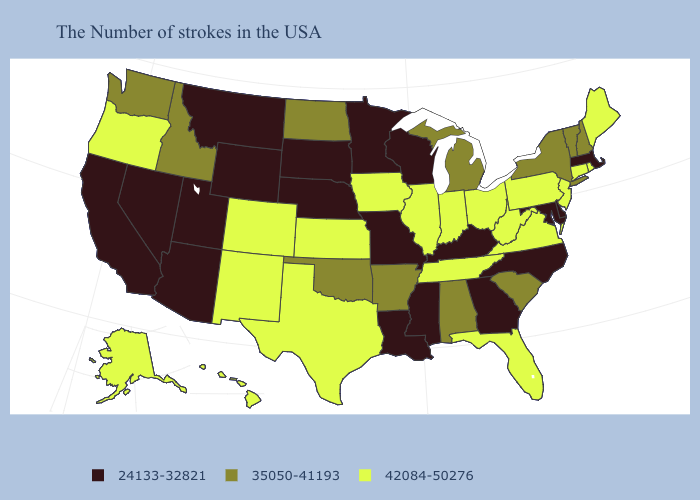What is the value of Wisconsin?
Keep it brief. 24133-32821. Among the states that border South Dakota , which have the lowest value?
Give a very brief answer. Minnesota, Nebraska, Wyoming, Montana. Name the states that have a value in the range 42084-50276?
Keep it brief. Maine, Rhode Island, Connecticut, New Jersey, Pennsylvania, Virginia, West Virginia, Ohio, Florida, Indiana, Tennessee, Illinois, Iowa, Kansas, Texas, Colorado, New Mexico, Oregon, Alaska, Hawaii. Among the states that border Nebraska , which have the lowest value?
Quick response, please. Missouri, South Dakota, Wyoming. Name the states that have a value in the range 24133-32821?
Short answer required. Massachusetts, Delaware, Maryland, North Carolina, Georgia, Kentucky, Wisconsin, Mississippi, Louisiana, Missouri, Minnesota, Nebraska, South Dakota, Wyoming, Utah, Montana, Arizona, Nevada, California. Among the states that border Rhode Island , which have the lowest value?
Write a very short answer. Massachusetts. Does Wisconsin have a lower value than Hawaii?
Keep it brief. Yes. Among the states that border Kentucky , does Missouri have the highest value?
Write a very short answer. No. Does Oklahoma have the highest value in the South?
Short answer required. No. Does Georgia have the lowest value in the South?
Answer briefly. Yes. Name the states that have a value in the range 35050-41193?
Write a very short answer. New Hampshire, Vermont, New York, South Carolina, Michigan, Alabama, Arkansas, Oklahoma, North Dakota, Idaho, Washington. What is the highest value in the MidWest ?
Short answer required. 42084-50276. Which states have the lowest value in the MidWest?
Quick response, please. Wisconsin, Missouri, Minnesota, Nebraska, South Dakota. Name the states that have a value in the range 35050-41193?
Be succinct. New Hampshire, Vermont, New York, South Carolina, Michigan, Alabama, Arkansas, Oklahoma, North Dakota, Idaho, Washington. Does Arizona have the highest value in the West?
Give a very brief answer. No. 